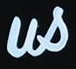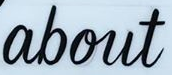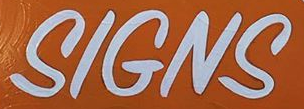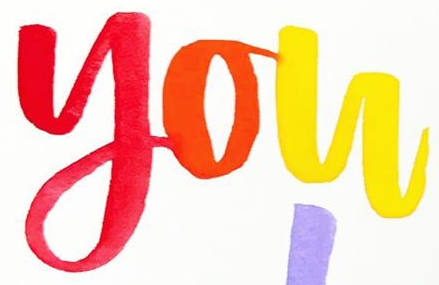What words are shown in these images in order, separated by a semicolon? us; about; SIGNS; you 